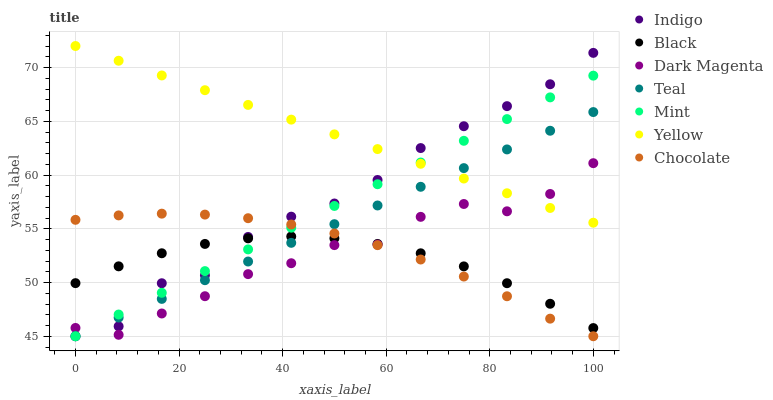Does Black have the minimum area under the curve?
Answer yes or no. Yes. Does Yellow have the maximum area under the curve?
Answer yes or no. Yes. Does Dark Magenta have the minimum area under the curve?
Answer yes or no. No. Does Dark Magenta have the maximum area under the curve?
Answer yes or no. No. Is Teal the smoothest?
Answer yes or no. Yes. Is Dark Magenta the roughest?
Answer yes or no. Yes. Is Yellow the smoothest?
Answer yes or no. No. Is Yellow the roughest?
Answer yes or no. No. Does Indigo have the lowest value?
Answer yes or no. Yes. Does Dark Magenta have the lowest value?
Answer yes or no. No. Does Yellow have the highest value?
Answer yes or no. Yes. Does Dark Magenta have the highest value?
Answer yes or no. No. Is Chocolate less than Yellow?
Answer yes or no. Yes. Is Yellow greater than Black?
Answer yes or no. Yes. Does Chocolate intersect Teal?
Answer yes or no. Yes. Is Chocolate less than Teal?
Answer yes or no. No. Is Chocolate greater than Teal?
Answer yes or no. No. Does Chocolate intersect Yellow?
Answer yes or no. No. 